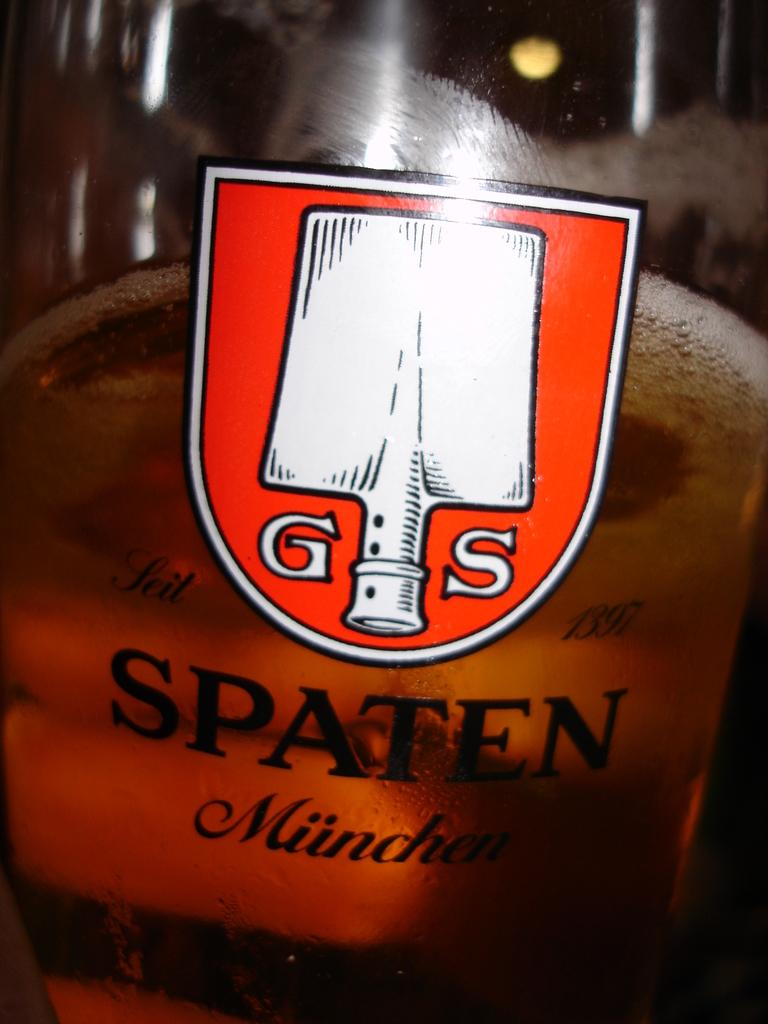Provide a one-sentence caption for the provided image. The logo for Spaten Munchen is displayed on a pint glass. 